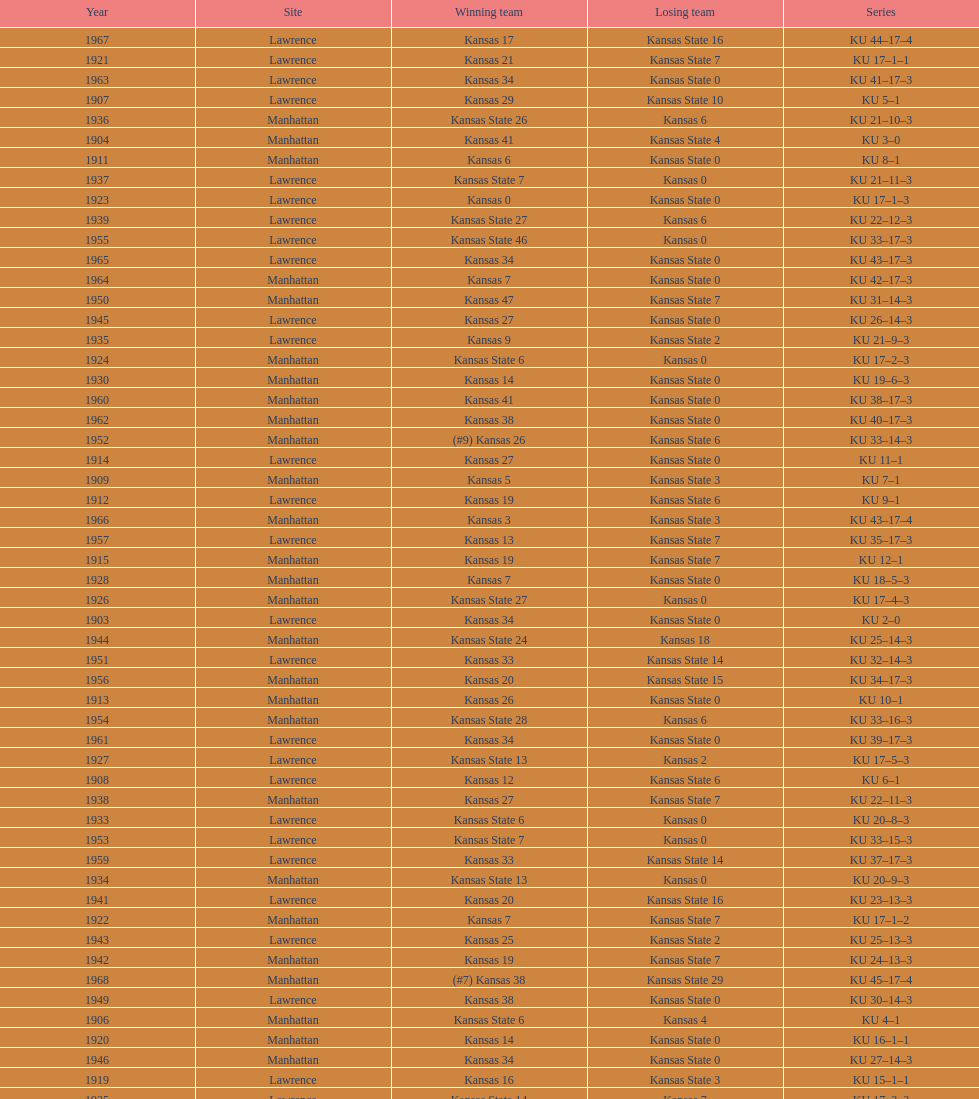When was the last time kansas state lost with 0 points in manhattan? 1964. 